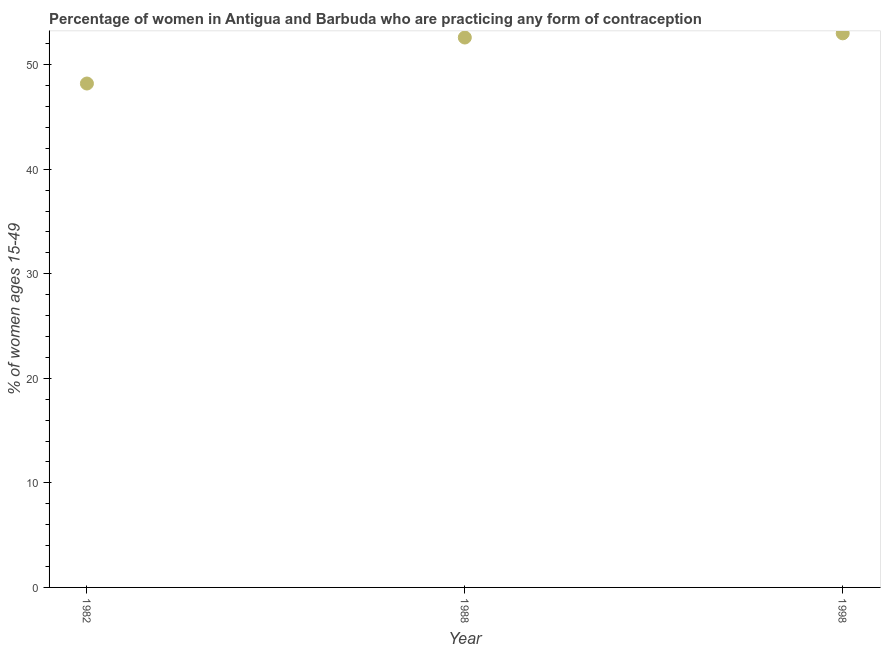What is the contraceptive prevalence in 1998?
Keep it short and to the point. 53. Across all years, what is the maximum contraceptive prevalence?
Give a very brief answer. 53. Across all years, what is the minimum contraceptive prevalence?
Give a very brief answer. 48.2. In which year was the contraceptive prevalence maximum?
Your answer should be very brief. 1998. In which year was the contraceptive prevalence minimum?
Offer a very short reply. 1982. What is the sum of the contraceptive prevalence?
Give a very brief answer. 153.8. What is the difference between the contraceptive prevalence in 1988 and 1998?
Keep it short and to the point. -0.4. What is the average contraceptive prevalence per year?
Make the answer very short. 51.27. What is the median contraceptive prevalence?
Your answer should be very brief. 52.6. What is the ratio of the contraceptive prevalence in 1982 to that in 1988?
Ensure brevity in your answer.  0.92. Is the contraceptive prevalence in 1982 less than that in 1998?
Offer a terse response. Yes. What is the difference between the highest and the second highest contraceptive prevalence?
Your answer should be compact. 0.4. Is the sum of the contraceptive prevalence in 1982 and 1988 greater than the maximum contraceptive prevalence across all years?
Provide a succinct answer. Yes. What is the difference between the highest and the lowest contraceptive prevalence?
Your answer should be compact. 4.8. In how many years, is the contraceptive prevalence greater than the average contraceptive prevalence taken over all years?
Keep it short and to the point. 2. Does the contraceptive prevalence monotonically increase over the years?
Keep it short and to the point. Yes. Are the values on the major ticks of Y-axis written in scientific E-notation?
Your answer should be compact. No. Does the graph contain grids?
Offer a very short reply. No. What is the title of the graph?
Offer a very short reply. Percentage of women in Antigua and Barbuda who are practicing any form of contraception. What is the label or title of the Y-axis?
Your answer should be very brief. % of women ages 15-49. What is the % of women ages 15-49 in 1982?
Your response must be concise. 48.2. What is the % of women ages 15-49 in 1988?
Your answer should be very brief. 52.6. What is the difference between the % of women ages 15-49 in 1982 and 1988?
Give a very brief answer. -4.4. What is the ratio of the % of women ages 15-49 in 1982 to that in 1988?
Your answer should be compact. 0.92. What is the ratio of the % of women ages 15-49 in 1982 to that in 1998?
Offer a terse response. 0.91. 